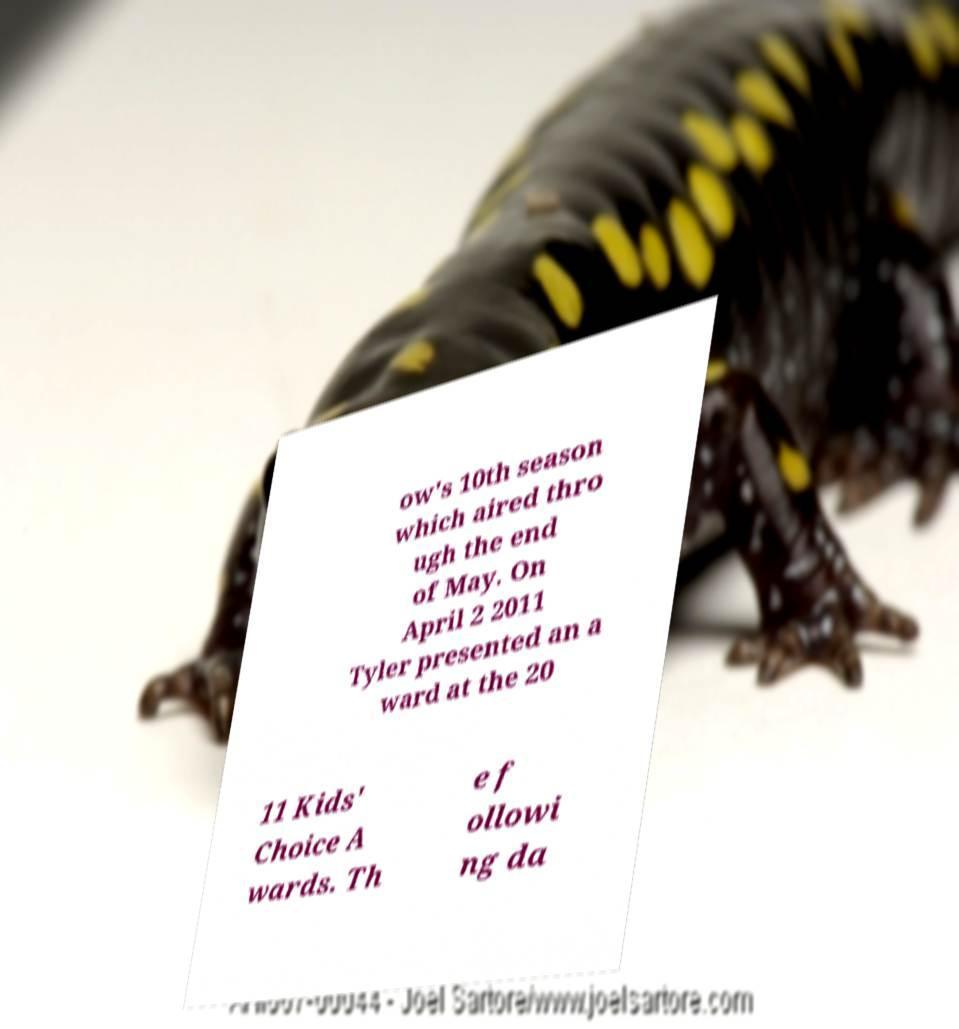For documentation purposes, I need the text within this image transcribed. Could you provide that? ow's 10th season which aired thro ugh the end of May. On April 2 2011 Tyler presented an a ward at the 20 11 Kids' Choice A wards. Th e f ollowi ng da 